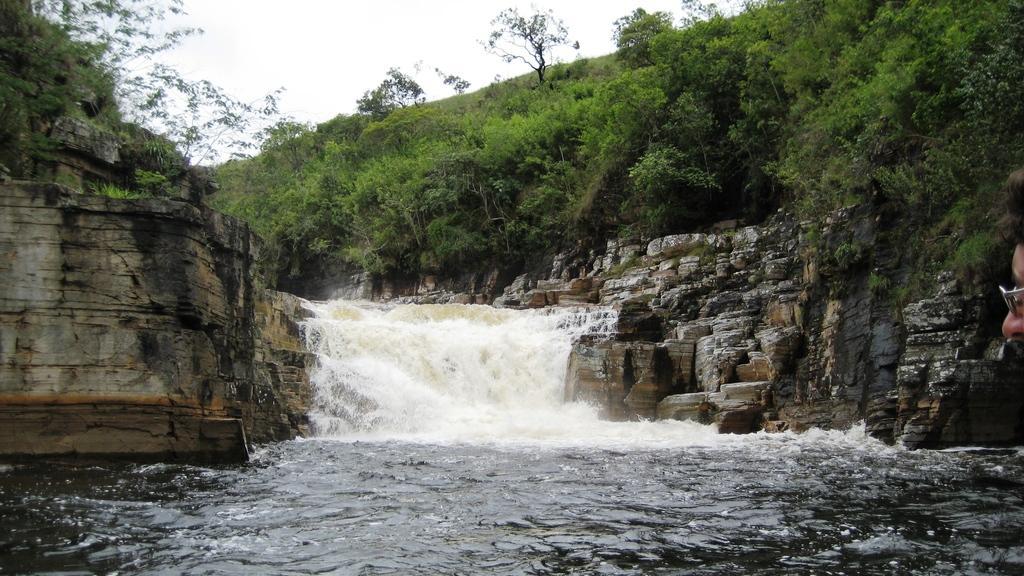Describe this image in one or two sentences. In this image we can see water flow, trees, plants, hill and sky. 